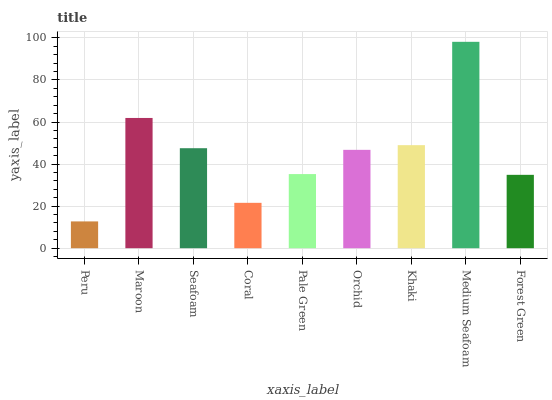Is Peru the minimum?
Answer yes or no. Yes. Is Medium Seafoam the maximum?
Answer yes or no. Yes. Is Maroon the minimum?
Answer yes or no. No. Is Maroon the maximum?
Answer yes or no. No. Is Maroon greater than Peru?
Answer yes or no. Yes. Is Peru less than Maroon?
Answer yes or no. Yes. Is Peru greater than Maroon?
Answer yes or no. No. Is Maroon less than Peru?
Answer yes or no. No. Is Orchid the high median?
Answer yes or no. Yes. Is Orchid the low median?
Answer yes or no. Yes. Is Khaki the high median?
Answer yes or no. No. Is Pale Green the low median?
Answer yes or no. No. 